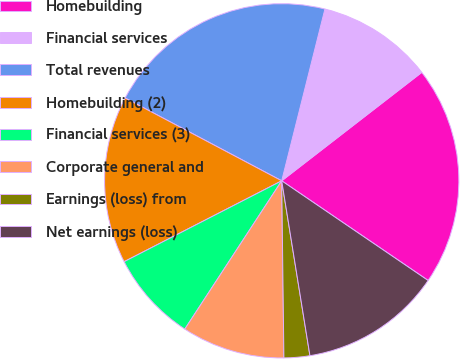Convert chart. <chart><loc_0><loc_0><loc_500><loc_500><pie_chart><fcel>Homebuilding<fcel>Financial services<fcel>Total revenues<fcel>Homebuilding (2)<fcel>Financial services (3)<fcel>Corporate general and<fcel>Earnings (loss) from<fcel>Net earnings (loss)<nl><fcel>20.0%<fcel>10.59%<fcel>21.18%<fcel>15.29%<fcel>8.24%<fcel>9.41%<fcel>2.35%<fcel>12.94%<nl></chart> 